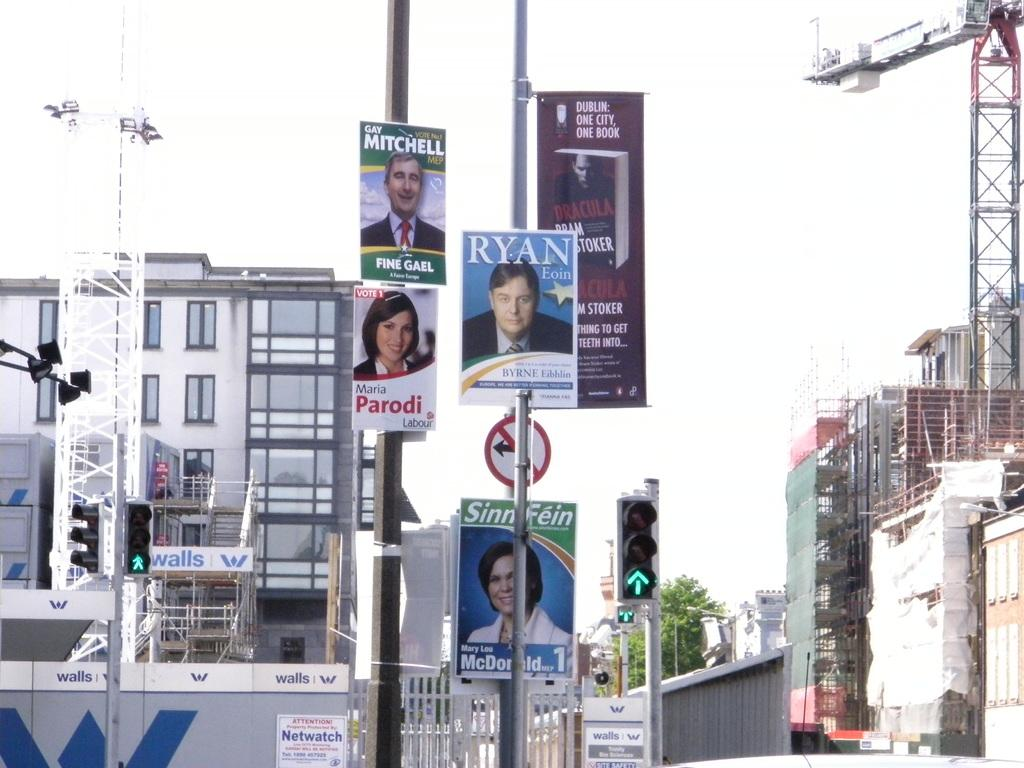Provide a one-sentence caption for the provided image. a neighborhood with sings on the poles of Ryan, Parodi and Mitchell. 